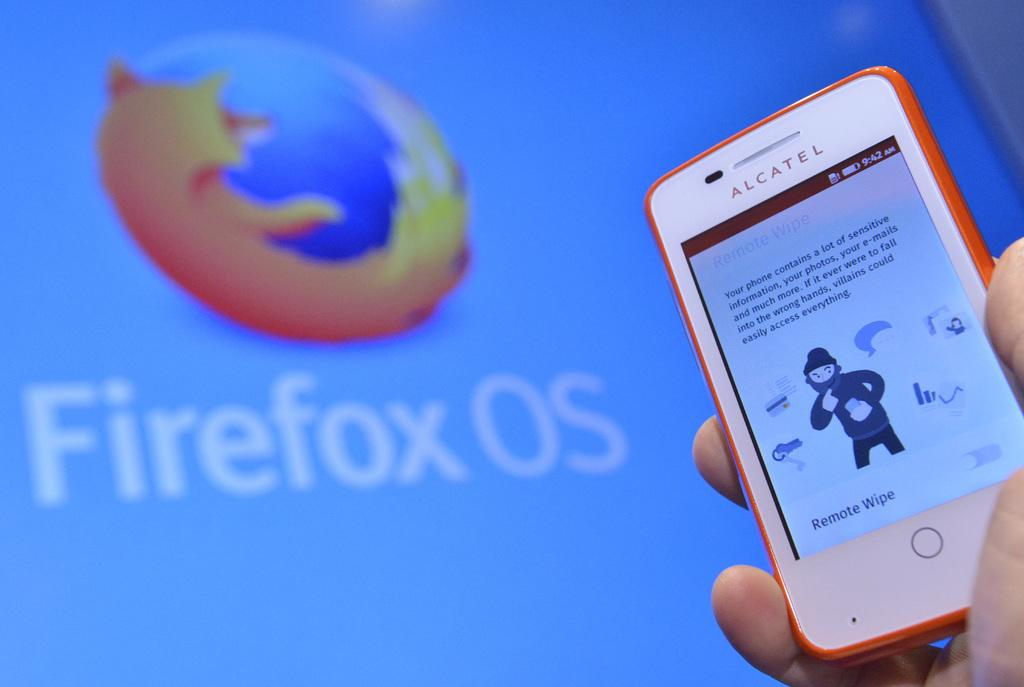<image>
Share a concise interpretation of the image provided. Firefox OS can be used on the Alcatel phone. 